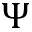<formula> <loc_0><loc_0><loc_500><loc_500>\Psi</formula> 